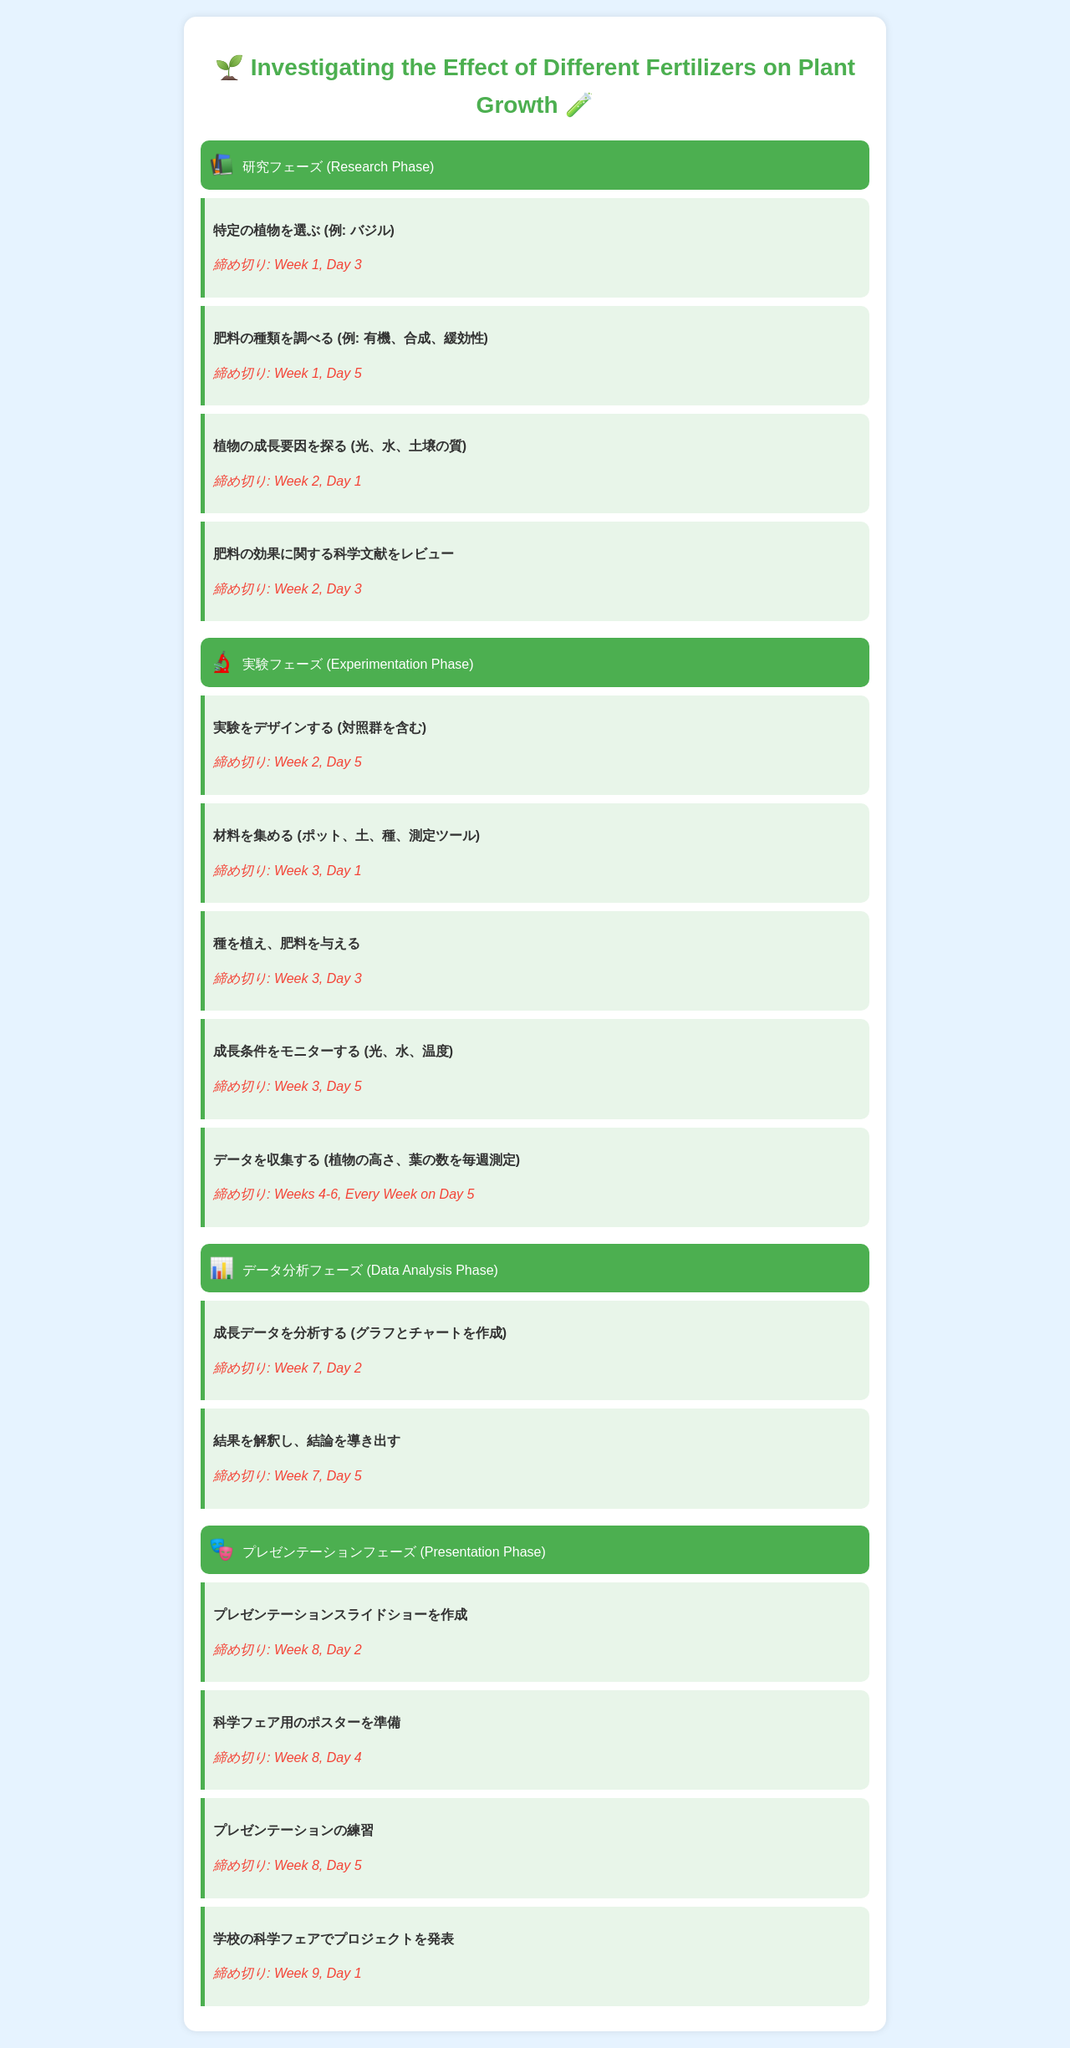what is the title of the project? The title of the project is stated at the top of the document, and it is focused on the effect of fertilizers on plant growth.
Answer: Investigating the Effect of Different Fertilizers on Plant Growth when is the deadline for selecting a plant? The deadline for selecting a plant is mentioned in the research phase activities, specifically after the activity about choosing a specific plant.
Answer: Week 1, Day 3 which type of phase comes after the experimentation phase? The document outlines the phases of the project, and after the experimentation phase, the next phase is indicated.
Answer: Data Analysis Phase how many weeks are data collected? The specific duration for which data is collected is stated during the data collection activity in the experimentation phase.
Answer: Weeks 4-6 what is the deadline for creating the presentation slides? The document specifies a deadline for creating the presentation slides in the presentation phase activities.
Answer: Week 8, Day 2 which type of fertilizer is mentioned as an example in the research phase? The document gives examples of fertilizer types in the research phase activities, specifying a particular category.
Answer: 有機 what day is the project presented at the science fair? The project presentation date at the science fair is given in the presentation phase activities at the end of the timeline.
Answer: Week 9, Day 1 what is the last activity listed in the timeline? The last activity in the timeline is the final step outlined in the presentation phase, signifying how the project concludes.
Answer: 学校の科学フェアでプロジェクトを発表 who is the target audience of the document based on the tone and content? The language and structure of the document indicate it is designed for a specific audience within an educational setting, particularly junior high students.
Answer: junior high students 